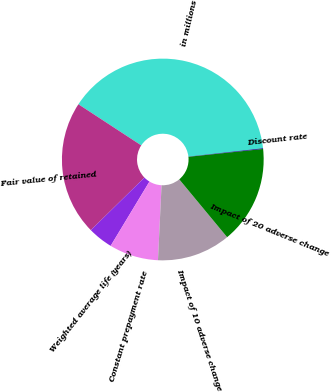Convert chart. <chart><loc_0><loc_0><loc_500><loc_500><pie_chart><fcel>in millions<fcel>Fair value of retained<fcel>Weighted average life (years)<fcel>Constant prepayment rate<fcel>Impact of 10 adverse change<fcel>Impact of 20 adverse change<fcel>Discount rate<nl><fcel>39.0%<fcel>21.58%<fcel>4.0%<fcel>7.88%<fcel>11.77%<fcel>15.66%<fcel>0.11%<nl></chart> 